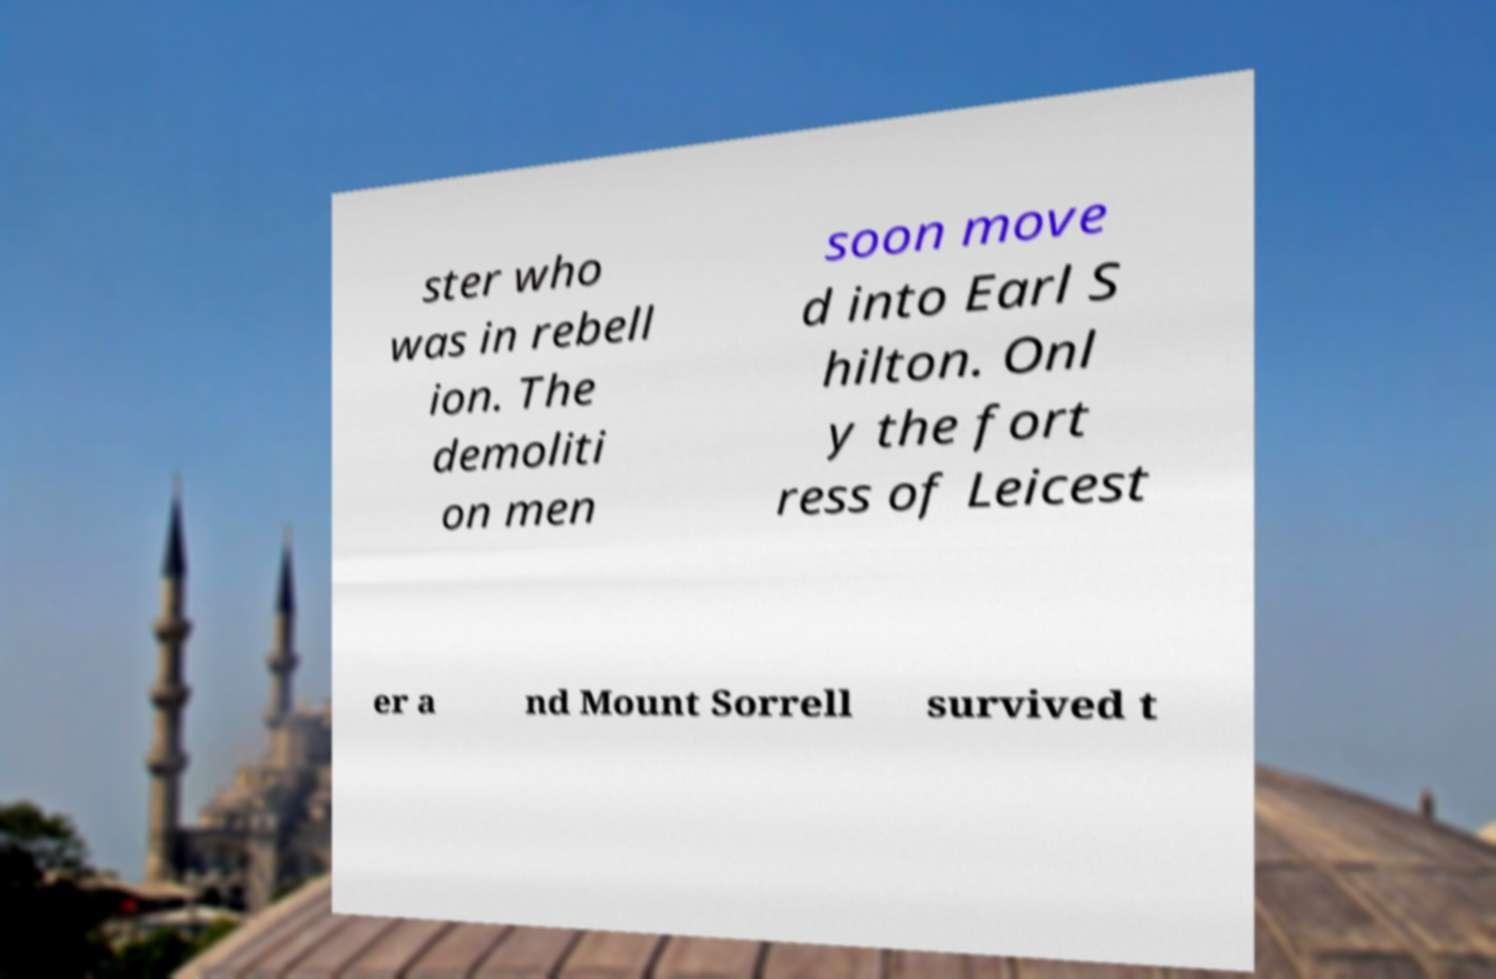Can you accurately transcribe the text from the provided image for me? ster who was in rebell ion. The demoliti on men soon move d into Earl S hilton. Onl y the fort ress of Leicest er a nd Mount Sorrell survived t 